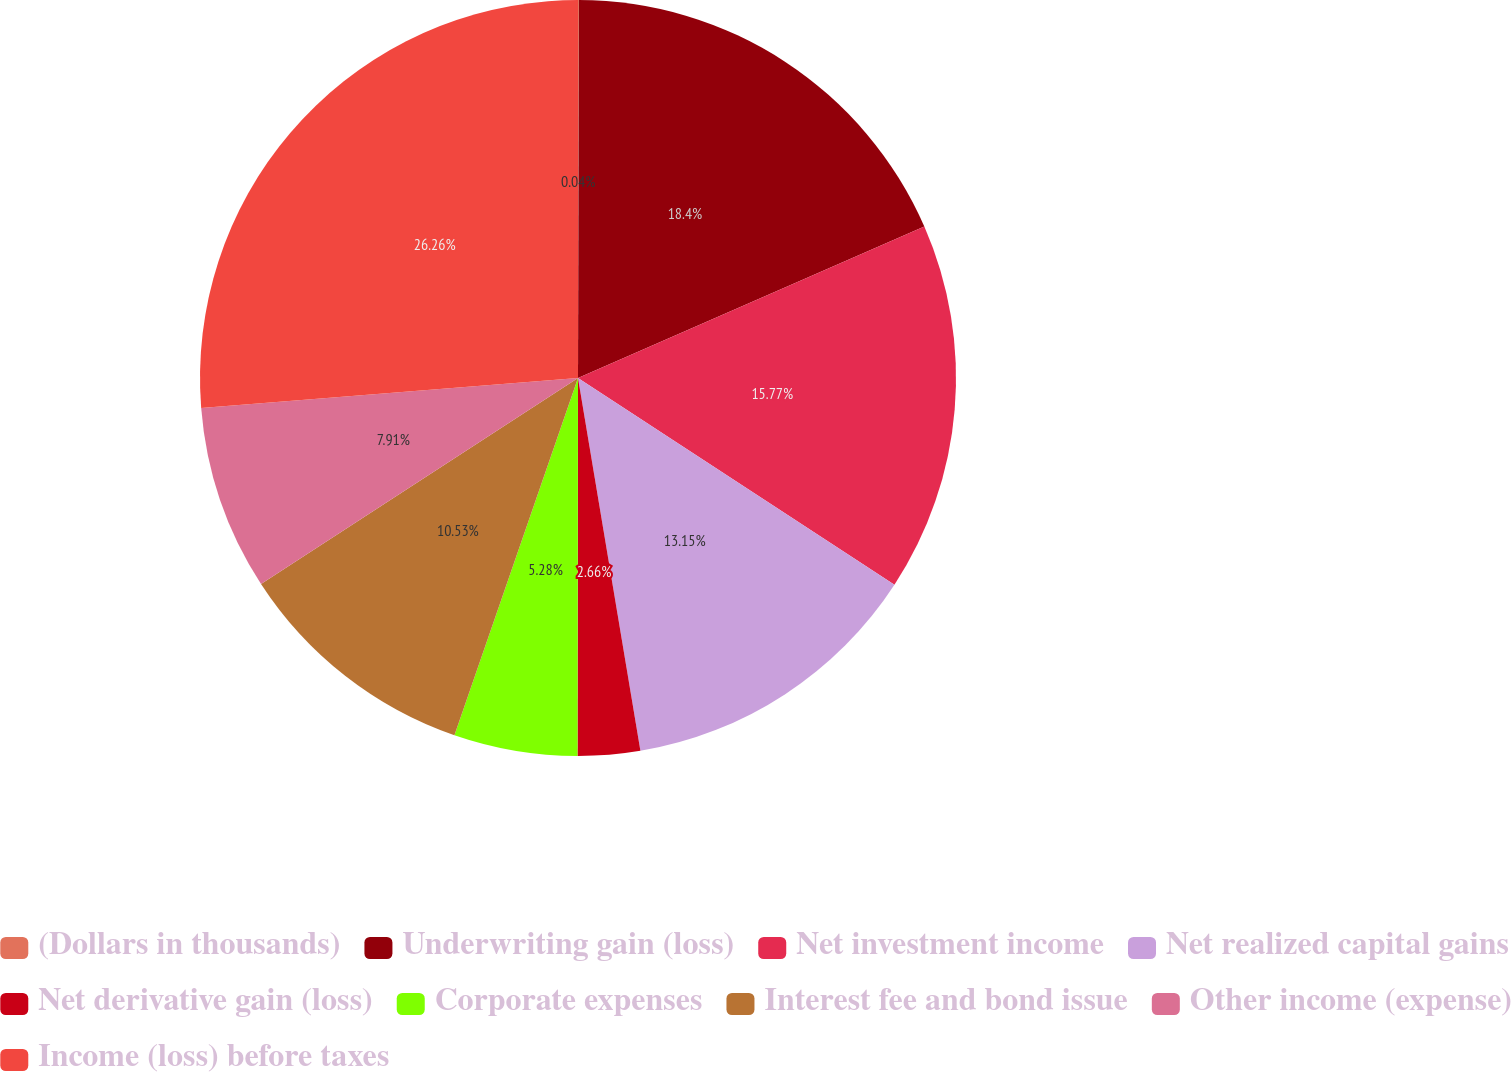<chart> <loc_0><loc_0><loc_500><loc_500><pie_chart><fcel>(Dollars in thousands)<fcel>Underwriting gain (loss)<fcel>Net investment income<fcel>Net realized capital gains<fcel>Net derivative gain (loss)<fcel>Corporate expenses<fcel>Interest fee and bond issue<fcel>Other income (expense)<fcel>Income (loss) before taxes<nl><fcel>0.04%<fcel>18.4%<fcel>15.77%<fcel>13.15%<fcel>2.66%<fcel>5.28%<fcel>10.53%<fcel>7.91%<fcel>26.26%<nl></chart> 